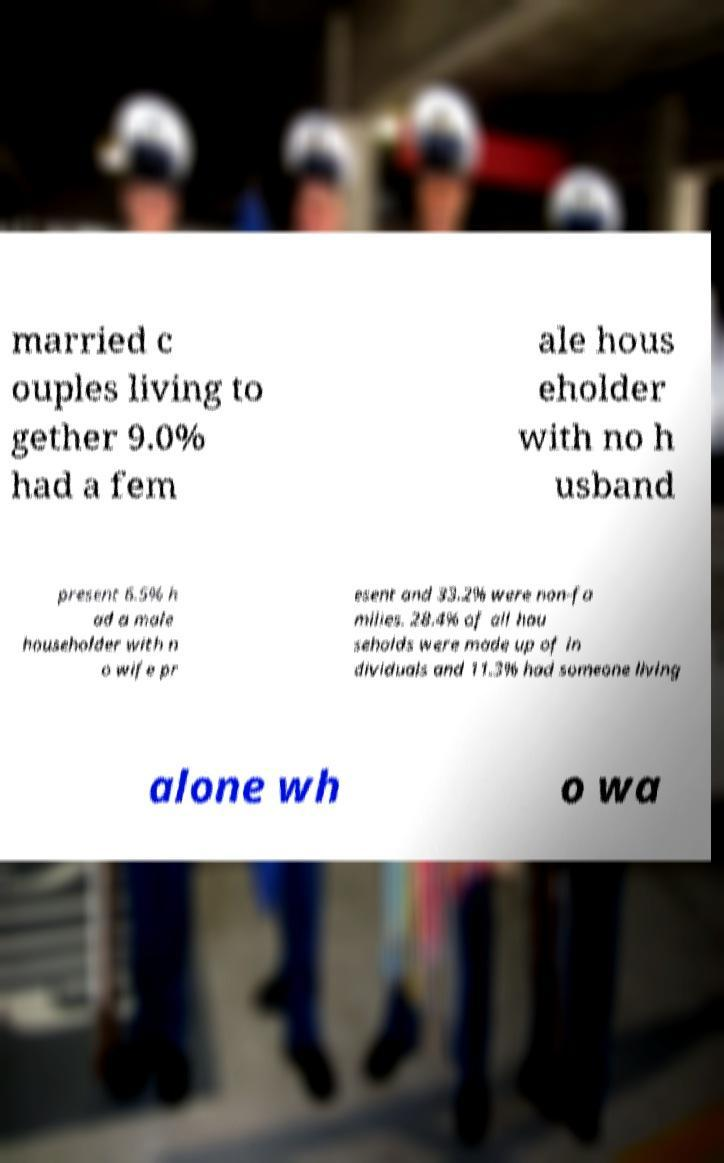For documentation purposes, I need the text within this image transcribed. Could you provide that? married c ouples living to gether 9.0% had a fem ale hous eholder with no h usband present 6.5% h ad a male householder with n o wife pr esent and 33.2% were non-fa milies. 28.4% of all hou seholds were made up of in dividuals and 11.3% had someone living alone wh o wa 